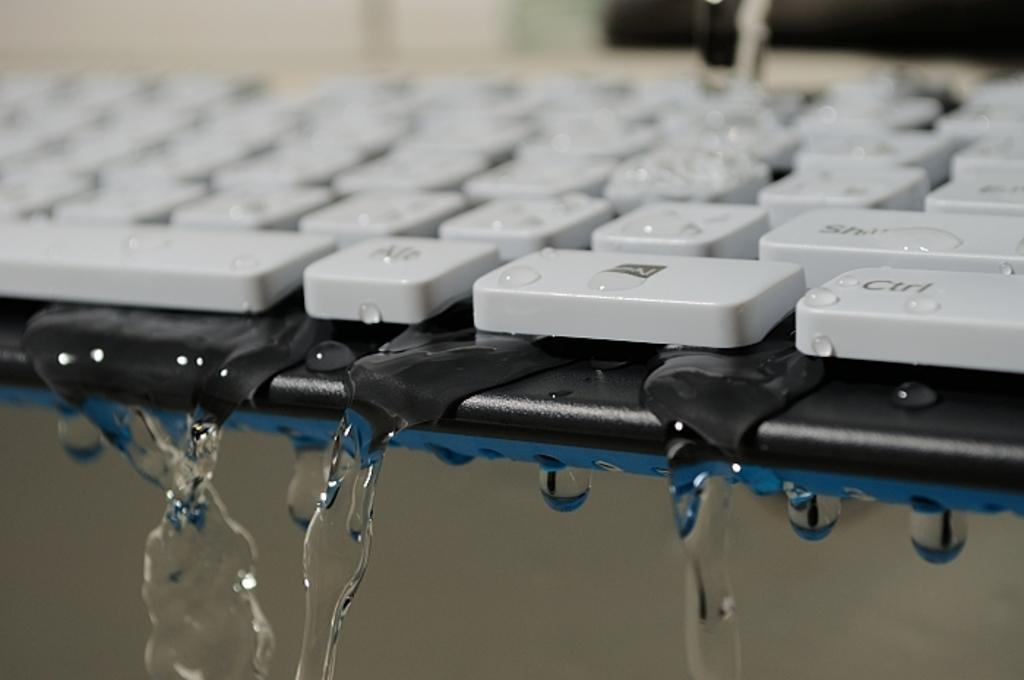<image>
Offer a succinct explanation of the picture presented. Water drips from underneath the Ctrl and Alt keys on a keyboard. 